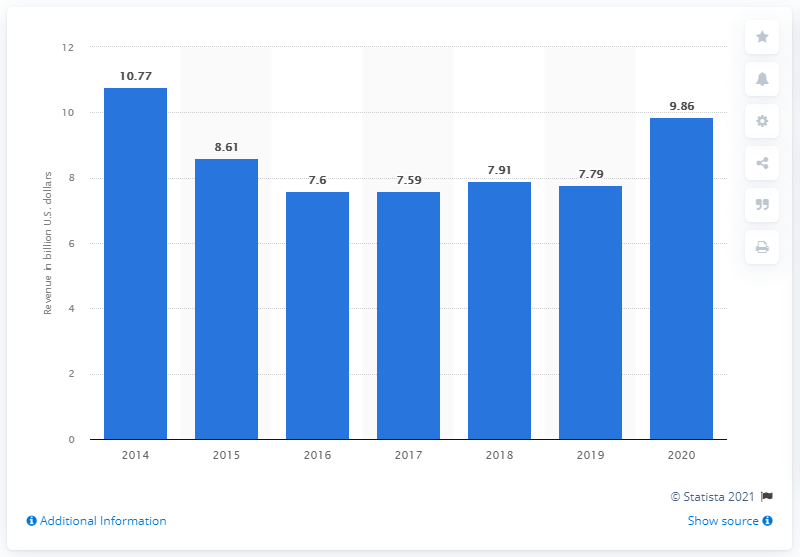Specify some key components in this picture. In 2020, Acer's revenue was approximately 9.86 billion dollars. 